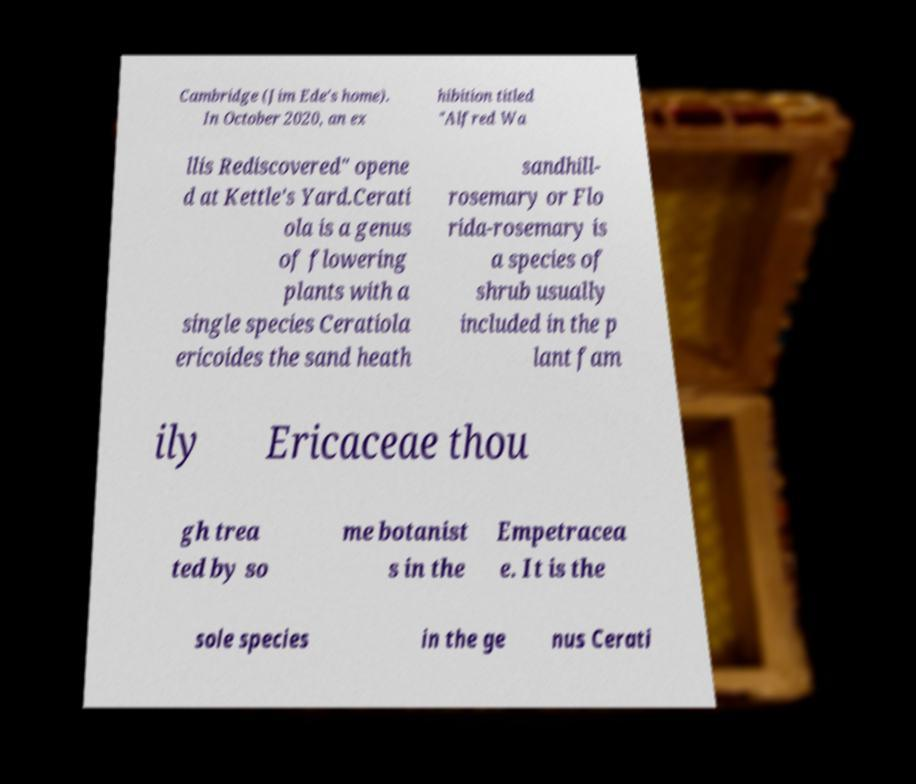For documentation purposes, I need the text within this image transcribed. Could you provide that? Cambridge (Jim Ede's home). In October 2020, an ex hibition titled "Alfred Wa llis Rediscovered" opene d at Kettle's Yard.Cerati ola is a genus of flowering plants with a single species Ceratiola ericoides the sand heath sandhill- rosemary or Flo rida-rosemary is a species of shrub usually included in the p lant fam ily Ericaceae thou gh trea ted by so me botanist s in the Empetracea e. It is the sole species in the ge nus Cerati 